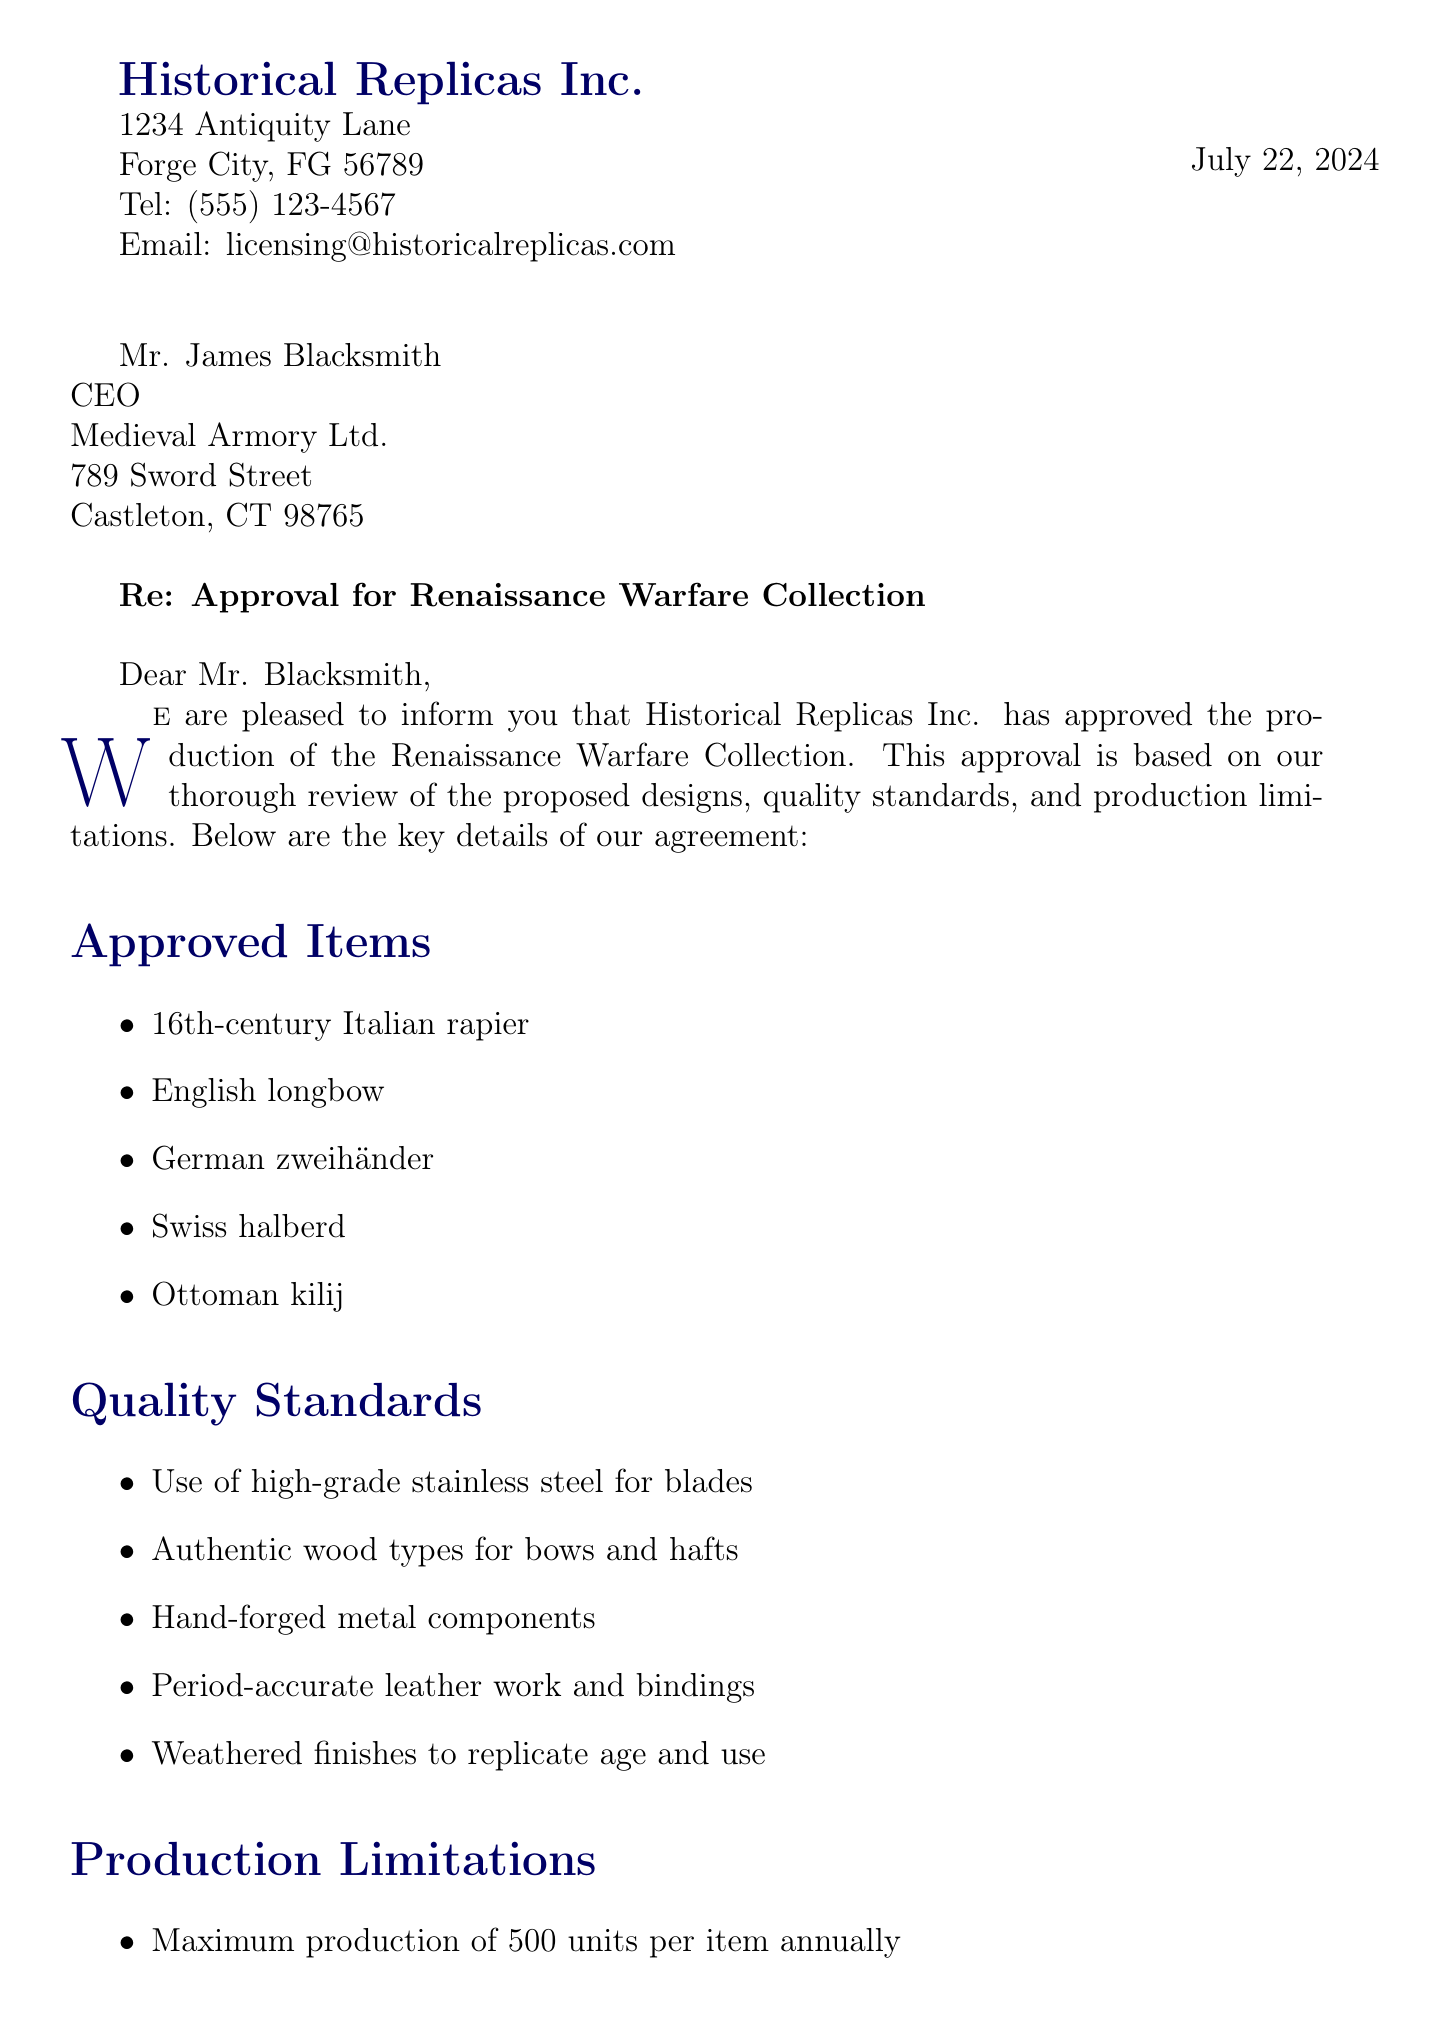What is the name of the replica line? The name of the replica line is explicitly stated in the document as "Renaissance Warfare Collection."
Answer: Renaissance Warfare Collection Who is the recipient of the letter? The recipient of the letter is named at the beginning of the document as Mr. James Blacksmith.
Answer: Mr. James Blacksmith What is the maximum production allowed per item annually? The document specifies that the maximum production allowed per item annually is stated as 500 units.
Answer: 500 units What must accompany each replica? It is detailed in the production limitations section that each replica must have a Certificate of authenticity.
Answer: Certificate of authenticity Which museum is mentioned as a resource for historical research? One of the museums mentioned as a resource for historical research is The Metropolitan Museum of Art.
Answer: The Metropolitan Museum of Art What type of warranty is provided for craftsmanship? The document states that a lifetime guarantee against defects in workmanship is provided for craftsmanship.
Answer: Lifetime guarantee What is the role of Sarah Licensington? The document indicates the role of Sarah Licensington as the Head of Licensing and Compliance.
Answer: Head of Licensing and Compliance What is prohibited for projectile weapons in the collection? The document outlines that no functional firing mechanisms are allowed for projectile weapons.
Answer: No functional firing mechanisms What age restriction is mentioned for the purchase of replicas? The document specifies that there is an age restriction for purchase, stating that only individuals aged 18 and above can buy the replicas.
Answer: 18+ only 